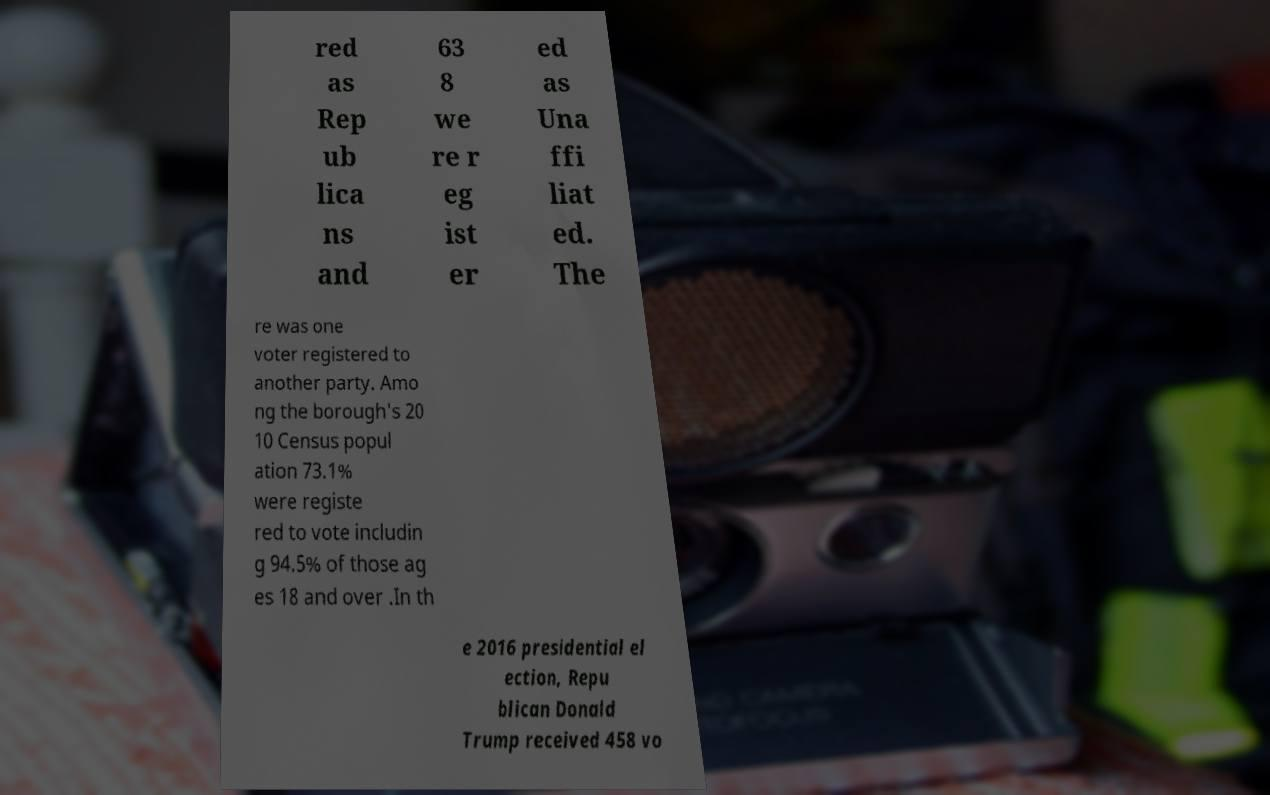Please identify and transcribe the text found in this image. red as Rep ub lica ns and 63 8 we re r eg ist er ed as Una ffi liat ed. The re was one voter registered to another party. Amo ng the borough's 20 10 Census popul ation 73.1% were registe red to vote includin g 94.5% of those ag es 18 and over .In th e 2016 presidential el ection, Repu blican Donald Trump received 458 vo 